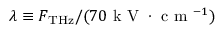Convert formula to latex. <formula><loc_0><loc_0><loc_500><loc_500>\lambda \equiv F _ { T H z } / ( 7 0 k V \cdot c m ^ { - 1 } )</formula> 